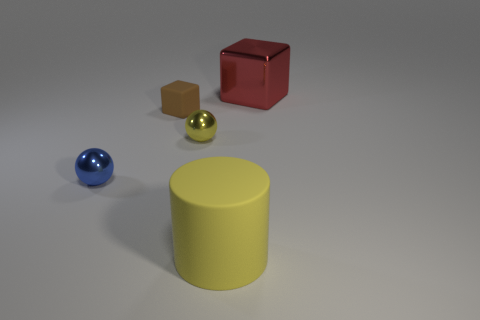Subtract all yellow balls. How many balls are left? 1 Add 5 yellow spheres. How many objects exist? 10 Subtract all blocks. How many objects are left? 3 Subtract all green metallic spheres. Subtract all yellow matte things. How many objects are left? 4 Add 1 big metallic blocks. How many big metallic blocks are left? 2 Add 5 spheres. How many spheres exist? 7 Subtract 1 brown blocks. How many objects are left? 4 Subtract 1 cylinders. How many cylinders are left? 0 Subtract all brown cylinders. Subtract all purple cubes. How many cylinders are left? 1 